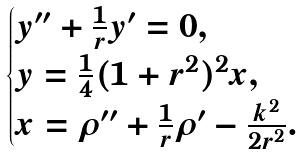Convert formula to latex. <formula><loc_0><loc_0><loc_500><loc_500>\begin{cases} y ^ { \prime \prime } + \frac { 1 } { r } y ^ { \prime } = 0 , \\ y = \frac { 1 } { 4 } ( 1 + r ^ { 2 } ) ^ { 2 } x , \\ x = \rho ^ { \prime \prime } + \frac { 1 } { r } \rho ^ { \prime } - \frac { k ^ { 2 } } { 2 r ^ { 2 } } . \end{cases}</formula> 